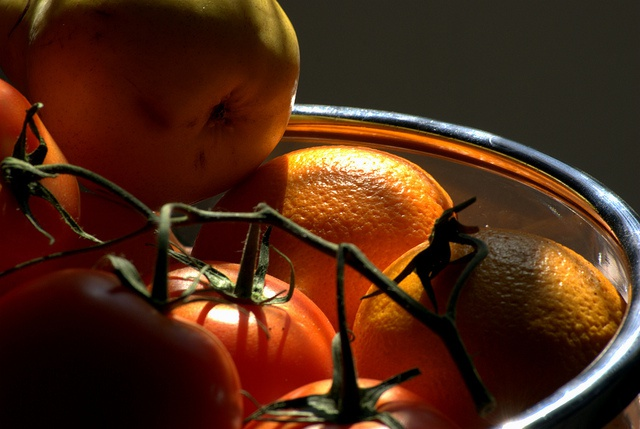Describe the objects in this image and their specific colors. I can see bowl in black, maroon, olive, and brown tones, orange in olive, black, maroon, brown, and orange tones, and orange in olive, maroon, and brown tones in this image. 